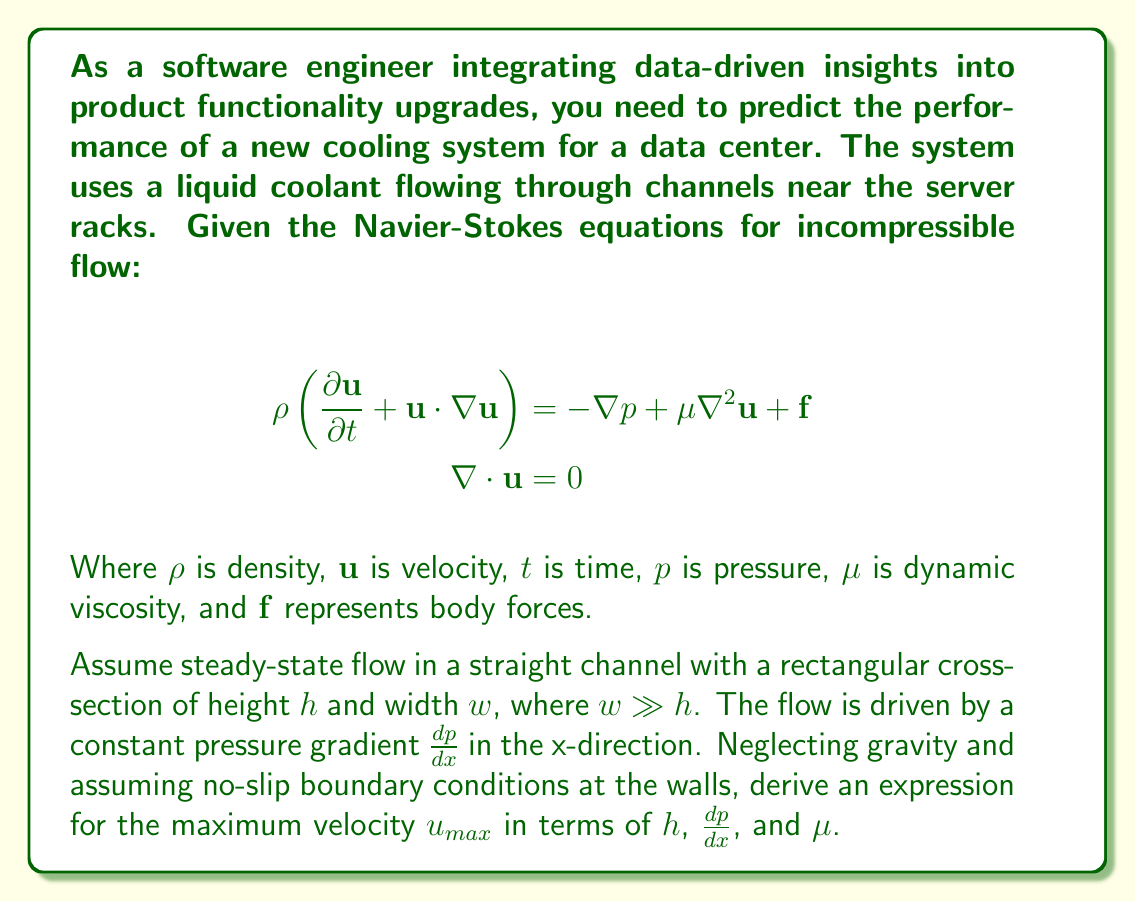Can you answer this question? To solve this problem, we'll follow these steps:

1) For steady-state flow in a straight channel, we can simplify the Navier-Stokes equations. The velocity will only have an x-component, and it will only depend on y and z.

2) The simplified equation becomes:

   $$\mu\left(\frac{\partial^2 u}{\partial y^2} + \frac{\partial^2 u}{\partial z^2}\right) = \frac{dp}{dx}$$

3) Since $w \gg h$, we can assume the flow is approximately two-dimensional and ignore variations in the z-direction. This further simplifies our equation to:

   $$\mu\frac{d^2 u}{dy^2} = \frac{dp}{dx}$$

4) We can integrate this twice with respect to y:

   $$\mu\frac{du}{dy} = \frac{dp}{dx}y + C_1$$
   $$\mu u = \frac{dp}{dx}\frac{y^2}{2} + C_1y + C_2$$

5) Apply the no-slip boundary conditions:
   At $y = 0$: $u = 0$, so $C_2 = 0$
   At $y = h$: $u = 0$, so $\frac{dp}{dx}\frac{h^2}{2} + C_1h = 0$

6) Solving for $C_1$:

   $$C_1 = -\frac{dp}{dx}\frac{h}{2}$$

7) Substituting back into our velocity equation:

   $$u = \frac{1}{\mu}\frac{dp}{dx}\left(\frac{y^2}{2} - \frac{hy}{2}\right)$$

8) To find the maximum velocity, we differentiate u with respect to y and set it to zero:

   $$\frac{du}{dy} = \frac{1}{\mu}\frac{dp}{dx}(y - \frac{h}{2}) = 0$$

   This occurs when $y = \frac{h}{2}$

9) Substituting this back into our velocity equation:

   $$u_{max} = \frac{1}{\mu}\frac{dp}{dx}\left(\frac{h^2}{8} - \frac{h^2}{4}\right) = -\frac{1}{8\mu}\frac{dp}{dx}h^2$$

10) The negative sign appears because $\frac{dp}{dx}$ is negative (pressure decreases in the flow direction). For a positive velocity, we can write:

    $$u_{max} = \frac{1}{8\mu}\left|-\frac{dp}{dx}\right|h^2$$
Answer: $$u_{max} = \frac{1}{8\mu}\left|-\frac{dp}{dx}\right|h^2$$ 